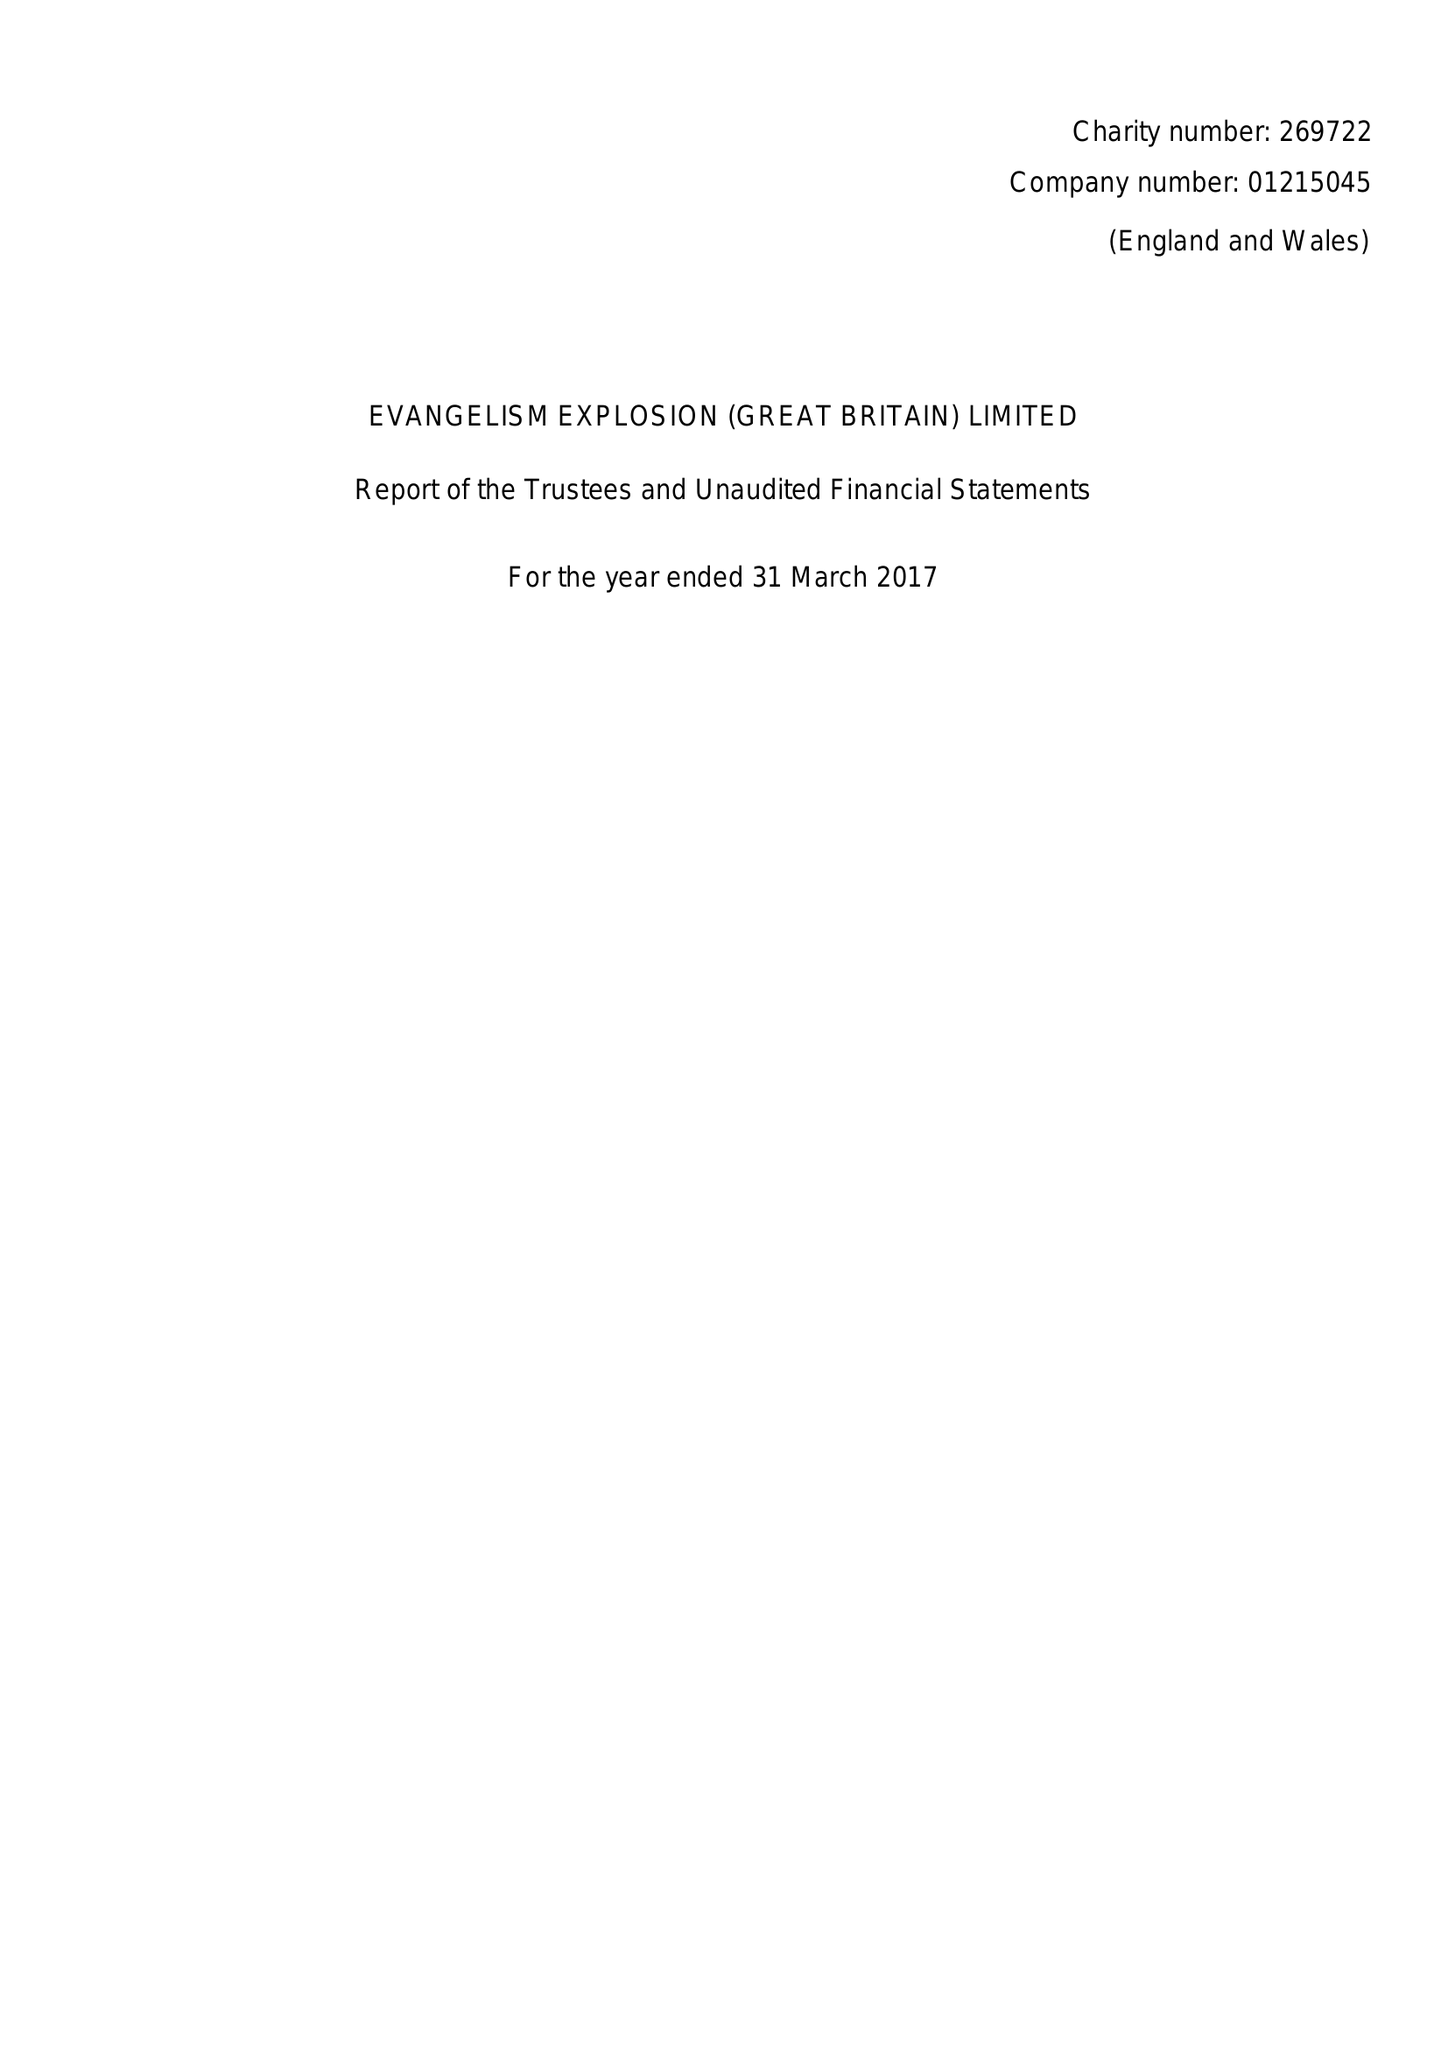What is the value for the charity_name?
Answer the question using a single word or phrase. Evangelism Explosion (Great Britain) Ltd. 